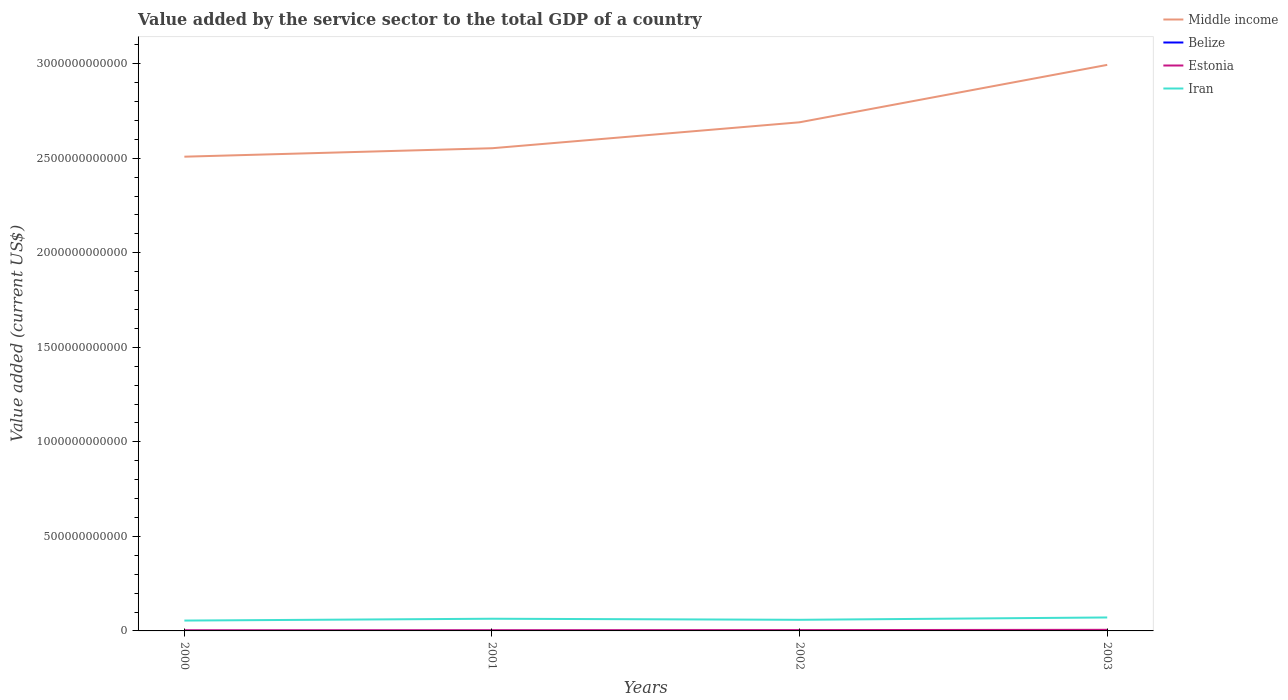How many different coloured lines are there?
Ensure brevity in your answer.  4. Does the line corresponding to Estonia intersect with the line corresponding to Middle income?
Your answer should be very brief. No. Across all years, what is the maximum value added by the service sector to the total GDP in Middle income?
Provide a short and direct response. 2.51e+12. What is the total value added by the service sector to the total GDP in Iran in the graph?
Your answer should be compact. 5.62e+09. What is the difference between the highest and the second highest value added by the service sector to the total GDP in Iran?
Provide a succinct answer. 1.64e+1. How many lines are there?
Your answer should be very brief. 4. How many years are there in the graph?
Your answer should be very brief. 4. What is the difference between two consecutive major ticks on the Y-axis?
Keep it short and to the point. 5.00e+11. Are the values on the major ticks of Y-axis written in scientific E-notation?
Ensure brevity in your answer.  No. Does the graph contain any zero values?
Your response must be concise. No. Does the graph contain grids?
Offer a very short reply. No. What is the title of the graph?
Your answer should be very brief. Value added by the service sector to the total GDP of a country. What is the label or title of the X-axis?
Your response must be concise. Years. What is the label or title of the Y-axis?
Offer a terse response. Value added (current US$). What is the Value added (current US$) of Middle income in 2000?
Offer a terse response. 2.51e+12. What is the Value added (current US$) in Belize in 2000?
Ensure brevity in your answer.  4.52e+08. What is the Value added (current US$) of Estonia in 2000?
Offer a very short reply. 3.42e+09. What is the Value added (current US$) in Iran in 2000?
Your answer should be very brief. 5.48e+1. What is the Value added (current US$) in Middle income in 2001?
Your answer should be very brief. 2.55e+12. What is the Value added (current US$) in Belize in 2001?
Offer a terse response. 4.84e+08. What is the Value added (current US$) in Estonia in 2001?
Offer a terse response. 3.72e+09. What is the Value added (current US$) of Iran in 2001?
Your answer should be compact. 6.45e+1. What is the Value added (current US$) in Middle income in 2002?
Provide a succinct answer. 2.69e+12. What is the Value added (current US$) of Belize in 2002?
Keep it short and to the point. 5.24e+08. What is the Value added (current US$) in Estonia in 2002?
Your answer should be compact. 4.37e+09. What is the Value added (current US$) in Iran in 2002?
Keep it short and to the point. 5.88e+1. What is the Value added (current US$) in Middle income in 2003?
Your response must be concise. 2.99e+12. What is the Value added (current US$) of Belize in 2003?
Your answer should be compact. 5.61e+08. What is the Value added (current US$) in Estonia in 2003?
Your answer should be very brief. 5.85e+09. What is the Value added (current US$) of Iran in 2003?
Offer a terse response. 7.12e+1. Across all years, what is the maximum Value added (current US$) of Middle income?
Offer a terse response. 2.99e+12. Across all years, what is the maximum Value added (current US$) in Belize?
Offer a terse response. 5.61e+08. Across all years, what is the maximum Value added (current US$) in Estonia?
Your response must be concise. 5.85e+09. Across all years, what is the maximum Value added (current US$) in Iran?
Give a very brief answer. 7.12e+1. Across all years, what is the minimum Value added (current US$) in Middle income?
Ensure brevity in your answer.  2.51e+12. Across all years, what is the minimum Value added (current US$) of Belize?
Your answer should be compact. 4.52e+08. Across all years, what is the minimum Value added (current US$) in Estonia?
Keep it short and to the point. 3.42e+09. Across all years, what is the minimum Value added (current US$) of Iran?
Provide a succinct answer. 5.48e+1. What is the total Value added (current US$) in Middle income in the graph?
Offer a terse response. 1.07e+13. What is the total Value added (current US$) of Belize in the graph?
Keep it short and to the point. 2.02e+09. What is the total Value added (current US$) in Estonia in the graph?
Provide a short and direct response. 1.74e+1. What is the total Value added (current US$) in Iran in the graph?
Make the answer very short. 2.49e+11. What is the difference between the Value added (current US$) in Middle income in 2000 and that in 2001?
Your answer should be very brief. -4.47e+1. What is the difference between the Value added (current US$) in Belize in 2000 and that in 2001?
Make the answer very short. -3.26e+07. What is the difference between the Value added (current US$) in Estonia in 2000 and that in 2001?
Ensure brevity in your answer.  -3.03e+08. What is the difference between the Value added (current US$) in Iran in 2000 and that in 2001?
Give a very brief answer. -9.68e+09. What is the difference between the Value added (current US$) in Middle income in 2000 and that in 2002?
Your answer should be compact. -1.82e+11. What is the difference between the Value added (current US$) in Belize in 2000 and that in 2002?
Offer a terse response. -7.26e+07. What is the difference between the Value added (current US$) in Estonia in 2000 and that in 2002?
Keep it short and to the point. -9.45e+08. What is the difference between the Value added (current US$) of Iran in 2000 and that in 2002?
Keep it short and to the point. -4.06e+09. What is the difference between the Value added (current US$) in Middle income in 2000 and that in 2003?
Provide a succinct answer. -4.86e+11. What is the difference between the Value added (current US$) of Belize in 2000 and that in 2003?
Provide a succinct answer. -1.10e+08. What is the difference between the Value added (current US$) in Estonia in 2000 and that in 2003?
Offer a very short reply. -2.43e+09. What is the difference between the Value added (current US$) of Iran in 2000 and that in 2003?
Give a very brief answer. -1.64e+1. What is the difference between the Value added (current US$) of Middle income in 2001 and that in 2002?
Offer a very short reply. -1.37e+11. What is the difference between the Value added (current US$) in Belize in 2001 and that in 2002?
Offer a terse response. -3.99e+07. What is the difference between the Value added (current US$) in Estonia in 2001 and that in 2002?
Provide a succinct answer. -6.42e+08. What is the difference between the Value added (current US$) in Iran in 2001 and that in 2002?
Offer a very short reply. 5.62e+09. What is the difference between the Value added (current US$) of Middle income in 2001 and that in 2003?
Offer a terse response. -4.41e+11. What is the difference between the Value added (current US$) of Belize in 2001 and that in 2003?
Offer a very short reply. -7.72e+07. What is the difference between the Value added (current US$) of Estonia in 2001 and that in 2003?
Your response must be concise. -2.13e+09. What is the difference between the Value added (current US$) in Iran in 2001 and that in 2003?
Ensure brevity in your answer.  -6.72e+09. What is the difference between the Value added (current US$) of Middle income in 2002 and that in 2003?
Provide a short and direct response. -3.04e+11. What is the difference between the Value added (current US$) in Belize in 2002 and that in 2003?
Offer a terse response. -3.73e+07. What is the difference between the Value added (current US$) in Estonia in 2002 and that in 2003?
Provide a succinct answer. -1.49e+09. What is the difference between the Value added (current US$) in Iran in 2002 and that in 2003?
Your response must be concise. -1.23e+1. What is the difference between the Value added (current US$) in Middle income in 2000 and the Value added (current US$) in Belize in 2001?
Your answer should be very brief. 2.51e+12. What is the difference between the Value added (current US$) of Middle income in 2000 and the Value added (current US$) of Estonia in 2001?
Provide a short and direct response. 2.50e+12. What is the difference between the Value added (current US$) in Middle income in 2000 and the Value added (current US$) in Iran in 2001?
Provide a succinct answer. 2.44e+12. What is the difference between the Value added (current US$) of Belize in 2000 and the Value added (current US$) of Estonia in 2001?
Keep it short and to the point. -3.27e+09. What is the difference between the Value added (current US$) in Belize in 2000 and the Value added (current US$) in Iran in 2001?
Your answer should be compact. -6.40e+1. What is the difference between the Value added (current US$) in Estonia in 2000 and the Value added (current US$) in Iran in 2001?
Offer a terse response. -6.10e+1. What is the difference between the Value added (current US$) in Middle income in 2000 and the Value added (current US$) in Belize in 2002?
Give a very brief answer. 2.51e+12. What is the difference between the Value added (current US$) of Middle income in 2000 and the Value added (current US$) of Estonia in 2002?
Give a very brief answer. 2.50e+12. What is the difference between the Value added (current US$) in Middle income in 2000 and the Value added (current US$) in Iran in 2002?
Provide a succinct answer. 2.45e+12. What is the difference between the Value added (current US$) in Belize in 2000 and the Value added (current US$) in Estonia in 2002?
Your answer should be very brief. -3.91e+09. What is the difference between the Value added (current US$) in Belize in 2000 and the Value added (current US$) in Iran in 2002?
Keep it short and to the point. -5.84e+1. What is the difference between the Value added (current US$) of Estonia in 2000 and the Value added (current US$) of Iran in 2002?
Give a very brief answer. -5.54e+1. What is the difference between the Value added (current US$) of Middle income in 2000 and the Value added (current US$) of Belize in 2003?
Keep it short and to the point. 2.51e+12. What is the difference between the Value added (current US$) in Middle income in 2000 and the Value added (current US$) in Estonia in 2003?
Your response must be concise. 2.50e+12. What is the difference between the Value added (current US$) in Middle income in 2000 and the Value added (current US$) in Iran in 2003?
Provide a succinct answer. 2.44e+12. What is the difference between the Value added (current US$) in Belize in 2000 and the Value added (current US$) in Estonia in 2003?
Provide a succinct answer. -5.40e+09. What is the difference between the Value added (current US$) of Belize in 2000 and the Value added (current US$) of Iran in 2003?
Give a very brief answer. -7.07e+1. What is the difference between the Value added (current US$) of Estonia in 2000 and the Value added (current US$) of Iran in 2003?
Give a very brief answer. -6.78e+1. What is the difference between the Value added (current US$) of Middle income in 2001 and the Value added (current US$) of Belize in 2002?
Offer a very short reply. 2.55e+12. What is the difference between the Value added (current US$) in Middle income in 2001 and the Value added (current US$) in Estonia in 2002?
Your response must be concise. 2.55e+12. What is the difference between the Value added (current US$) in Middle income in 2001 and the Value added (current US$) in Iran in 2002?
Your answer should be compact. 2.49e+12. What is the difference between the Value added (current US$) in Belize in 2001 and the Value added (current US$) in Estonia in 2002?
Provide a succinct answer. -3.88e+09. What is the difference between the Value added (current US$) of Belize in 2001 and the Value added (current US$) of Iran in 2002?
Offer a terse response. -5.84e+1. What is the difference between the Value added (current US$) in Estonia in 2001 and the Value added (current US$) in Iran in 2002?
Keep it short and to the point. -5.51e+1. What is the difference between the Value added (current US$) in Middle income in 2001 and the Value added (current US$) in Belize in 2003?
Your response must be concise. 2.55e+12. What is the difference between the Value added (current US$) of Middle income in 2001 and the Value added (current US$) of Estonia in 2003?
Offer a very short reply. 2.55e+12. What is the difference between the Value added (current US$) of Middle income in 2001 and the Value added (current US$) of Iran in 2003?
Provide a short and direct response. 2.48e+12. What is the difference between the Value added (current US$) of Belize in 2001 and the Value added (current US$) of Estonia in 2003?
Provide a short and direct response. -5.37e+09. What is the difference between the Value added (current US$) in Belize in 2001 and the Value added (current US$) in Iran in 2003?
Ensure brevity in your answer.  -7.07e+1. What is the difference between the Value added (current US$) of Estonia in 2001 and the Value added (current US$) of Iran in 2003?
Your answer should be compact. -6.75e+1. What is the difference between the Value added (current US$) of Middle income in 2002 and the Value added (current US$) of Belize in 2003?
Provide a succinct answer. 2.69e+12. What is the difference between the Value added (current US$) of Middle income in 2002 and the Value added (current US$) of Estonia in 2003?
Ensure brevity in your answer.  2.68e+12. What is the difference between the Value added (current US$) of Middle income in 2002 and the Value added (current US$) of Iran in 2003?
Provide a short and direct response. 2.62e+12. What is the difference between the Value added (current US$) of Belize in 2002 and the Value added (current US$) of Estonia in 2003?
Your answer should be very brief. -5.33e+09. What is the difference between the Value added (current US$) of Belize in 2002 and the Value added (current US$) of Iran in 2003?
Your answer should be compact. -7.07e+1. What is the difference between the Value added (current US$) in Estonia in 2002 and the Value added (current US$) in Iran in 2003?
Your response must be concise. -6.68e+1. What is the average Value added (current US$) of Middle income per year?
Keep it short and to the point. 2.69e+12. What is the average Value added (current US$) of Belize per year?
Ensure brevity in your answer.  5.05e+08. What is the average Value added (current US$) in Estonia per year?
Your response must be concise. 4.34e+09. What is the average Value added (current US$) in Iran per year?
Provide a short and direct response. 6.23e+1. In the year 2000, what is the difference between the Value added (current US$) in Middle income and Value added (current US$) in Belize?
Your answer should be very brief. 2.51e+12. In the year 2000, what is the difference between the Value added (current US$) in Middle income and Value added (current US$) in Estonia?
Your answer should be very brief. 2.50e+12. In the year 2000, what is the difference between the Value added (current US$) of Middle income and Value added (current US$) of Iran?
Keep it short and to the point. 2.45e+12. In the year 2000, what is the difference between the Value added (current US$) in Belize and Value added (current US$) in Estonia?
Provide a short and direct response. -2.97e+09. In the year 2000, what is the difference between the Value added (current US$) in Belize and Value added (current US$) in Iran?
Ensure brevity in your answer.  -5.43e+1. In the year 2000, what is the difference between the Value added (current US$) of Estonia and Value added (current US$) of Iran?
Offer a very short reply. -5.14e+1. In the year 2001, what is the difference between the Value added (current US$) of Middle income and Value added (current US$) of Belize?
Ensure brevity in your answer.  2.55e+12. In the year 2001, what is the difference between the Value added (current US$) of Middle income and Value added (current US$) of Estonia?
Provide a succinct answer. 2.55e+12. In the year 2001, what is the difference between the Value added (current US$) in Middle income and Value added (current US$) in Iran?
Give a very brief answer. 2.49e+12. In the year 2001, what is the difference between the Value added (current US$) of Belize and Value added (current US$) of Estonia?
Make the answer very short. -3.24e+09. In the year 2001, what is the difference between the Value added (current US$) in Belize and Value added (current US$) in Iran?
Ensure brevity in your answer.  -6.40e+1. In the year 2001, what is the difference between the Value added (current US$) in Estonia and Value added (current US$) in Iran?
Provide a succinct answer. -6.07e+1. In the year 2002, what is the difference between the Value added (current US$) of Middle income and Value added (current US$) of Belize?
Offer a very short reply. 2.69e+12. In the year 2002, what is the difference between the Value added (current US$) of Middle income and Value added (current US$) of Estonia?
Your answer should be very brief. 2.69e+12. In the year 2002, what is the difference between the Value added (current US$) of Middle income and Value added (current US$) of Iran?
Your response must be concise. 2.63e+12. In the year 2002, what is the difference between the Value added (current US$) of Belize and Value added (current US$) of Estonia?
Ensure brevity in your answer.  -3.84e+09. In the year 2002, what is the difference between the Value added (current US$) in Belize and Value added (current US$) in Iran?
Make the answer very short. -5.83e+1. In the year 2002, what is the difference between the Value added (current US$) in Estonia and Value added (current US$) in Iran?
Offer a very short reply. -5.45e+1. In the year 2003, what is the difference between the Value added (current US$) in Middle income and Value added (current US$) in Belize?
Keep it short and to the point. 2.99e+12. In the year 2003, what is the difference between the Value added (current US$) in Middle income and Value added (current US$) in Estonia?
Keep it short and to the point. 2.99e+12. In the year 2003, what is the difference between the Value added (current US$) of Middle income and Value added (current US$) of Iran?
Keep it short and to the point. 2.92e+12. In the year 2003, what is the difference between the Value added (current US$) of Belize and Value added (current US$) of Estonia?
Provide a short and direct response. -5.29e+09. In the year 2003, what is the difference between the Value added (current US$) of Belize and Value added (current US$) of Iran?
Make the answer very short. -7.06e+1. In the year 2003, what is the difference between the Value added (current US$) of Estonia and Value added (current US$) of Iran?
Your response must be concise. -6.53e+1. What is the ratio of the Value added (current US$) of Middle income in 2000 to that in 2001?
Ensure brevity in your answer.  0.98. What is the ratio of the Value added (current US$) in Belize in 2000 to that in 2001?
Provide a succinct answer. 0.93. What is the ratio of the Value added (current US$) of Estonia in 2000 to that in 2001?
Offer a terse response. 0.92. What is the ratio of the Value added (current US$) of Iran in 2000 to that in 2001?
Make the answer very short. 0.85. What is the ratio of the Value added (current US$) in Middle income in 2000 to that in 2002?
Your answer should be compact. 0.93. What is the ratio of the Value added (current US$) in Belize in 2000 to that in 2002?
Make the answer very short. 0.86. What is the ratio of the Value added (current US$) of Estonia in 2000 to that in 2002?
Your response must be concise. 0.78. What is the ratio of the Value added (current US$) in Iran in 2000 to that in 2002?
Offer a very short reply. 0.93. What is the ratio of the Value added (current US$) of Middle income in 2000 to that in 2003?
Offer a terse response. 0.84. What is the ratio of the Value added (current US$) of Belize in 2000 to that in 2003?
Make the answer very short. 0.8. What is the ratio of the Value added (current US$) in Estonia in 2000 to that in 2003?
Provide a short and direct response. 0.58. What is the ratio of the Value added (current US$) of Iran in 2000 to that in 2003?
Your response must be concise. 0.77. What is the ratio of the Value added (current US$) in Middle income in 2001 to that in 2002?
Provide a succinct answer. 0.95. What is the ratio of the Value added (current US$) of Belize in 2001 to that in 2002?
Make the answer very short. 0.92. What is the ratio of the Value added (current US$) in Estonia in 2001 to that in 2002?
Ensure brevity in your answer.  0.85. What is the ratio of the Value added (current US$) of Iran in 2001 to that in 2002?
Offer a very short reply. 1.1. What is the ratio of the Value added (current US$) of Middle income in 2001 to that in 2003?
Offer a very short reply. 0.85. What is the ratio of the Value added (current US$) in Belize in 2001 to that in 2003?
Give a very brief answer. 0.86. What is the ratio of the Value added (current US$) of Estonia in 2001 to that in 2003?
Offer a terse response. 0.64. What is the ratio of the Value added (current US$) of Iran in 2001 to that in 2003?
Provide a short and direct response. 0.91. What is the ratio of the Value added (current US$) in Middle income in 2002 to that in 2003?
Offer a terse response. 0.9. What is the ratio of the Value added (current US$) of Belize in 2002 to that in 2003?
Give a very brief answer. 0.93. What is the ratio of the Value added (current US$) of Estonia in 2002 to that in 2003?
Give a very brief answer. 0.75. What is the ratio of the Value added (current US$) in Iran in 2002 to that in 2003?
Give a very brief answer. 0.83. What is the difference between the highest and the second highest Value added (current US$) in Middle income?
Provide a short and direct response. 3.04e+11. What is the difference between the highest and the second highest Value added (current US$) of Belize?
Provide a succinct answer. 3.73e+07. What is the difference between the highest and the second highest Value added (current US$) in Estonia?
Your answer should be very brief. 1.49e+09. What is the difference between the highest and the second highest Value added (current US$) of Iran?
Provide a short and direct response. 6.72e+09. What is the difference between the highest and the lowest Value added (current US$) in Middle income?
Provide a short and direct response. 4.86e+11. What is the difference between the highest and the lowest Value added (current US$) in Belize?
Make the answer very short. 1.10e+08. What is the difference between the highest and the lowest Value added (current US$) of Estonia?
Offer a terse response. 2.43e+09. What is the difference between the highest and the lowest Value added (current US$) of Iran?
Ensure brevity in your answer.  1.64e+1. 